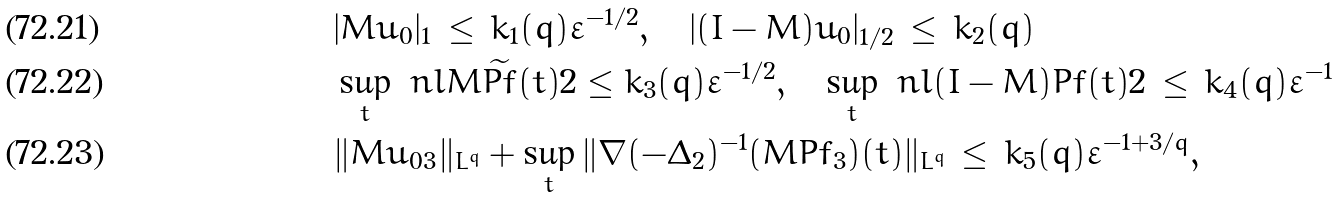<formula> <loc_0><loc_0><loc_500><loc_500>& | M u _ { 0 } | _ { 1 } \, \leq \, k _ { 1 } ( q ) \varepsilon ^ { - 1 / 2 } , \quad | ( I - M ) u _ { 0 } | _ { 1 / 2 } \, \leq \, k _ { 2 } ( q ) \\ & \sup _ { t } \ n l { M \widetilde { P f } ( t ) } { 2 } \leq k _ { 3 } ( q ) \varepsilon ^ { - 1 / 2 } , \quad \sup _ { t } \ n l { ( I - M ) P f ( t ) } { 2 } \, \leq \, k _ { 4 } ( q ) \varepsilon ^ { - 1 } \\ & \| M u _ { 0 3 } \| _ { L ^ { q } } + \sup _ { t } \| \nabla ( - \Delta _ { 2 } ) ^ { - 1 } ( M P f _ { 3 } ) ( t ) \| _ { L ^ { q } } \, \leq \, k _ { 5 } ( q ) \varepsilon ^ { - 1 + 3 / q } ,</formula> 